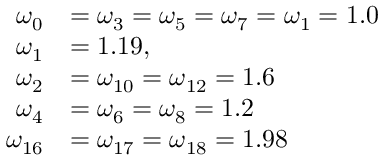<formula> <loc_0><loc_0><loc_500><loc_500>\begin{array} { r l } { \omega _ { 0 } } & { = \omega _ { 3 } = \omega _ { 5 } = \omega _ { 7 } = \omega _ { 1 } = 1 . 0 } \\ { \omega _ { 1 } } & { = 1 . 1 9 , } \\ { \omega _ { 2 } } & { = \omega _ { 1 0 } = \omega _ { 1 2 } = 1 . 6 } \\ { \omega _ { 4 } } & { = \omega _ { 6 } = \omega _ { 8 } = 1 . 2 } \\ { \omega _ { 1 6 } } & { = \omega _ { 1 7 } = \omega _ { 1 8 } = 1 . 9 8 } \end{array}</formula> 